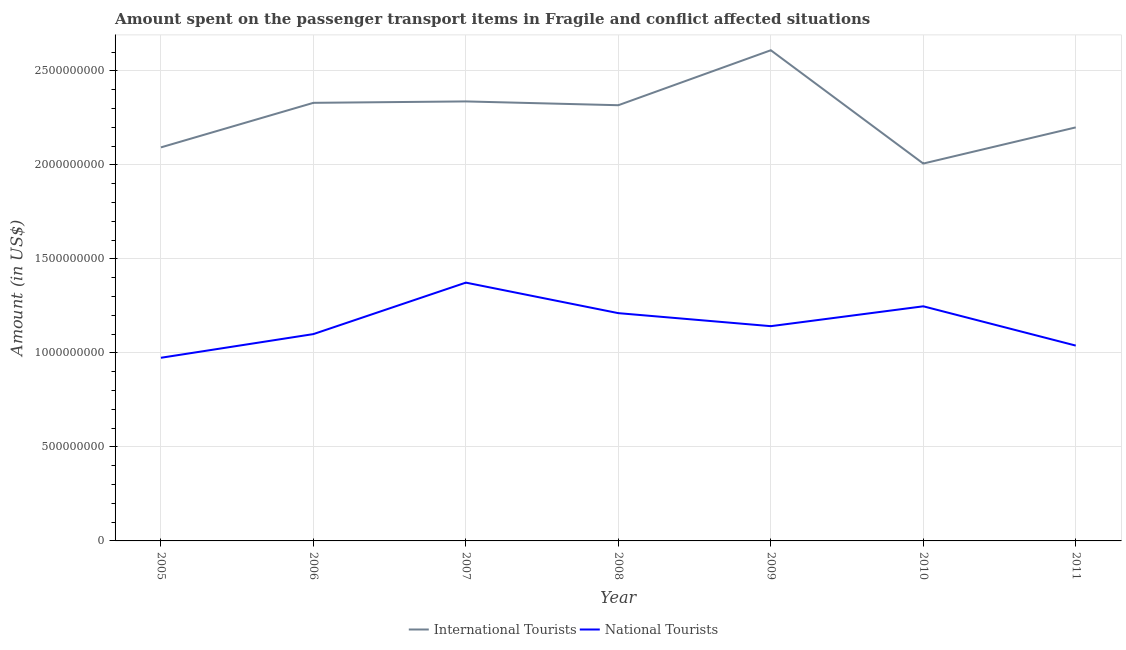Does the line corresponding to amount spent on transport items of international tourists intersect with the line corresponding to amount spent on transport items of national tourists?
Provide a short and direct response. No. Is the number of lines equal to the number of legend labels?
Offer a very short reply. Yes. What is the amount spent on transport items of international tourists in 2007?
Offer a terse response. 2.34e+09. Across all years, what is the maximum amount spent on transport items of international tourists?
Your answer should be compact. 2.61e+09. Across all years, what is the minimum amount spent on transport items of national tourists?
Keep it short and to the point. 9.74e+08. In which year was the amount spent on transport items of national tourists minimum?
Your answer should be compact. 2005. What is the total amount spent on transport items of international tourists in the graph?
Offer a terse response. 1.59e+1. What is the difference between the amount spent on transport items of international tourists in 2010 and that in 2011?
Offer a very short reply. -1.92e+08. What is the difference between the amount spent on transport items of international tourists in 2005 and the amount spent on transport items of national tourists in 2009?
Make the answer very short. 9.51e+08. What is the average amount spent on transport items of international tourists per year?
Your answer should be compact. 2.27e+09. In the year 2005, what is the difference between the amount spent on transport items of international tourists and amount spent on transport items of national tourists?
Make the answer very short. 1.12e+09. In how many years, is the amount spent on transport items of international tourists greater than 2200000000 US$?
Your response must be concise. 4. What is the ratio of the amount spent on transport items of international tourists in 2006 to that in 2007?
Provide a short and direct response. 1. What is the difference between the highest and the second highest amount spent on transport items of international tourists?
Your answer should be compact. 2.72e+08. What is the difference between the highest and the lowest amount spent on transport items of national tourists?
Make the answer very short. 4.00e+08. In how many years, is the amount spent on transport items of national tourists greater than the average amount spent on transport items of national tourists taken over all years?
Your response must be concise. 3. Is the amount spent on transport items of national tourists strictly less than the amount spent on transport items of international tourists over the years?
Give a very brief answer. Yes. How many years are there in the graph?
Offer a terse response. 7. What is the difference between two consecutive major ticks on the Y-axis?
Your answer should be very brief. 5.00e+08. Where does the legend appear in the graph?
Your response must be concise. Bottom center. What is the title of the graph?
Provide a short and direct response. Amount spent on the passenger transport items in Fragile and conflict affected situations. What is the label or title of the X-axis?
Make the answer very short. Year. What is the label or title of the Y-axis?
Offer a very short reply. Amount (in US$). What is the Amount (in US$) in International Tourists in 2005?
Offer a terse response. 2.09e+09. What is the Amount (in US$) in National Tourists in 2005?
Provide a succinct answer. 9.74e+08. What is the Amount (in US$) in International Tourists in 2006?
Your answer should be very brief. 2.33e+09. What is the Amount (in US$) of National Tourists in 2006?
Give a very brief answer. 1.10e+09. What is the Amount (in US$) of International Tourists in 2007?
Your response must be concise. 2.34e+09. What is the Amount (in US$) of National Tourists in 2007?
Give a very brief answer. 1.37e+09. What is the Amount (in US$) of International Tourists in 2008?
Make the answer very short. 2.32e+09. What is the Amount (in US$) in National Tourists in 2008?
Ensure brevity in your answer.  1.21e+09. What is the Amount (in US$) of International Tourists in 2009?
Your answer should be very brief. 2.61e+09. What is the Amount (in US$) of National Tourists in 2009?
Give a very brief answer. 1.14e+09. What is the Amount (in US$) of International Tourists in 2010?
Offer a terse response. 2.01e+09. What is the Amount (in US$) in National Tourists in 2010?
Make the answer very short. 1.25e+09. What is the Amount (in US$) of International Tourists in 2011?
Offer a very short reply. 2.20e+09. What is the Amount (in US$) in National Tourists in 2011?
Provide a succinct answer. 1.04e+09. Across all years, what is the maximum Amount (in US$) of International Tourists?
Provide a short and direct response. 2.61e+09. Across all years, what is the maximum Amount (in US$) in National Tourists?
Provide a short and direct response. 1.37e+09. Across all years, what is the minimum Amount (in US$) of International Tourists?
Your answer should be compact. 2.01e+09. Across all years, what is the minimum Amount (in US$) of National Tourists?
Offer a terse response. 9.74e+08. What is the total Amount (in US$) of International Tourists in the graph?
Offer a terse response. 1.59e+1. What is the total Amount (in US$) of National Tourists in the graph?
Provide a succinct answer. 8.09e+09. What is the difference between the Amount (in US$) in International Tourists in 2005 and that in 2006?
Make the answer very short. -2.37e+08. What is the difference between the Amount (in US$) in National Tourists in 2005 and that in 2006?
Your response must be concise. -1.26e+08. What is the difference between the Amount (in US$) in International Tourists in 2005 and that in 2007?
Make the answer very short. -2.44e+08. What is the difference between the Amount (in US$) in National Tourists in 2005 and that in 2007?
Offer a very short reply. -4.00e+08. What is the difference between the Amount (in US$) of International Tourists in 2005 and that in 2008?
Your response must be concise. -2.24e+08. What is the difference between the Amount (in US$) of National Tourists in 2005 and that in 2008?
Your answer should be compact. -2.37e+08. What is the difference between the Amount (in US$) of International Tourists in 2005 and that in 2009?
Keep it short and to the point. -5.17e+08. What is the difference between the Amount (in US$) in National Tourists in 2005 and that in 2009?
Offer a very short reply. -1.68e+08. What is the difference between the Amount (in US$) of International Tourists in 2005 and that in 2010?
Offer a terse response. 8.60e+07. What is the difference between the Amount (in US$) in National Tourists in 2005 and that in 2010?
Provide a succinct answer. -2.74e+08. What is the difference between the Amount (in US$) in International Tourists in 2005 and that in 2011?
Provide a short and direct response. -1.06e+08. What is the difference between the Amount (in US$) in National Tourists in 2005 and that in 2011?
Make the answer very short. -6.48e+07. What is the difference between the Amount (in US$) of International Tourists in 2006 and that in 2007?
Provide a short and direct response. -7.46e+06. What is the difference between the Amount (in US$) of National Tourists in 2006 and that in 2007?
Keep it short and to the point. -2.74e+08. What is the difference between the Amount (in US$) in International Tourists in 2006 and that in 2008?
Keep it short and to the point. 1.27e+07. What is the difference between the Amount (in US$) in National Tourists in 2006 and that in 2008?
Provide a short and direct response. -1.11e+08. What is the difference between the Amount (in US$) of International Tourists in 2006 and that in 2009?
Provide a short and direct response. -2.80e+08. What is the difference between the Amount (in US$) in National Tourists in 2006 and that in 2009?
Make the answer very short. -4.22e+07. What is the difference between the Amount (in US$) in International Tourists in 2006 and that in 2010?
Your answer should be compact. 3.23e+08. What is the difference between the Amount (in US$) in National Tourists in 2006 and that in 2010?
Provide a succinct answer. -1.48e+08. What is the difference between the Amount (in US$) of International Tourists in 2006 and that in 2011?
Your answer should be very brief. 1.31e+08. What is the difference between the Amount (in US$) in National Tourists in 2006 and that in 2011?
Ensure brevity in your answer.  6.11e+07. What is the difference between the Amount (in US$) of International Tourists in 2007 and that in 2008?
Keep it short and to the point. 2.02e+07. What is the difference between the Amount (in US$) of National Tourists in 2007 and that in 2008?
Your answer should be very brief. 1.62e+08. What is the difference between the Amount (in US$) in International Tourists in 2007 and that in 2009?
Your answer should be compact. -2.72e+08. What is the difference between the Amount (in US$) of National Tourists in 2007 and that in 2009?
Provide a succinct answer. 2.32e+08. What is the difference between the Amount (in US$) of International Tourists in 2007 and that in 2010?
Make the answer very short. 3.30e+08. What is the difference between the Amount (in US$) in National Tourists in 2007 and that in 2010?
Offer a very short reply. 1.26e+08. What is the difference between the Amount (in US$) in International Tourists in 2007 and that in 2011?
Your answer should be very brief. 1.38e+08. What is the difference between the Amount (in US$) in National Tourists in 2007 and that in 2011?
Ensure brevity in your answer.  3.35e+08. What is the difference between the Amount (in US$) of International Tourists in 2008 and that in 2009?
Provide a succinct answer. -2.92e+08. What is the difference between the Amount (in US$) of National Tourists in 2008 and that in 2009?
Give a very brief answer. 6.92e+07. What is the difference between the Amount (in US$) of International Tourists in 2008 and that in 2010?
Offer a terse response. 3.10e+08. What is the difference between the Amount (in US$) in National Tourists in 2008 and that in 2010?
Give a very brief answer. -3.64e+07. What is the difference between the Amount (in US$) in International Tourists in 2008 and that in 2011?
Offer a very short reply. 1.18e+08. What is the difference between the Amount (in US$) of National Tourists in 2008 and that in 2011?
Give a very brief answer. 1.73e+08. What is the difference between the Amount (in US$) of International Tourists in 2009 and that in 2010?
Offer a terse response. 6.03e+08. What is the difference between the Amount (in US$) of National Tourists in 2009 and that in 2010?
Ensure brevity in your answer.  -1.06e+08. What is the difference between the Amount (in US$) in International Tourists in 2009 and that in 2011?
Your answer should be very brief. 4.10e+08. What is the difference between the Amount (in US$) of National Tourists in 2009 and that in 2011?
Give a very brief answer. 1.03e+08. What is the difference between the Amount (in US$) in International Tourists in 2010 and that in 2011?
Provide a succinct answer. -1.92e+08. What is the difference between the Amount (in US$) of National Tourists in 2010 and that in 2011?
Provide a succinct answer. 2.09e+08. What is the difference between the Amount (in US$) of International Tourists in 2005 and the Amount (in US$) of National Tourists in 2006?
Offer a very short reply. 9.93e+08. What is the difference between the Amount (in US$) in International Tourists in 2005 and the Amount (in US$) in National Tourists in 2007?
Provide a succinct answer. 7.19e+08. What is the difference between the Amount (in US$) of International Tourists in 2005 and the Amount (in US$) of National Tourists in 2008?
Provide a short and direct response. 8.82e+08. What is the difference between the Amount (in US$) of International Tourists in 2005 and the Amount (in US$) of National Tourists in 2009?
Ensure brevity in your answer.  9.51e+08. What is the difference between the Amount (in US$) of International Tourists in 2005 and the Amount (in US$) of National Tourists in 2010?
Offer a very short reply. 8.45e+08. What is the difference between the Amount (in US$) in International Tourists in 2005 and the Amount (in US$) in National Tourists in 2011?
Make the answer very short. 1.05e+09. What is the difference between the Amount (in US$) in International Tourists in 2006 and the Amount (in US$) in National Tourists in 2007?
Make the answer very short. 9.56e+08. What is the difference between the Amount (in US$) of International Tourists in 2006 and the Amount (in US$) of National Tourists in 2008?
Your answer should be compact. 1.12e+09. What is the difference between the Amount (in US$) in International Tourists in 2006 and the Amount (in US$) in National Tourists in 2009?
Keep it short and to the point. 1.19e+09. What is the difference between the Amount (in US$) in International Tourists in 2006 and the Amount (in US$) in National Tourists in 2010?
Provide a short and direct response. 1.08e+09. What is the difference between the Amount (in US$) in International Tourists in 2006 and the Amount (in US$) in National Tourists in 2011?
Provide a succinct answer. 1.29e+09. What is the difference between the Amount (in US$) of International Tourists in 2007 and the Amount (in US$) of National Tourists in 2008?
Make the answer very short. 1.13e+09. What is the difference between the Amount (in US$) in International Tourists in 2007 and the Amount (in US$) in National Tourists in 2009?
Provide a short and direct response. 1.20e+09. What is the difference between the Amount (in US$) in International Tourists in 2007 and the Amount (in US$) in National Tourists in 2010?
Give a very brief answer. 1.09e+09. What is the difference between the Amount (in US$) in International Tourists in 2007 and the Amount (in US$) in National Tourists in 2011?
Offer a terse response. 1.30e+09. What is the difference between the Amount (in US$) of International Tourists in 2008 and the Amount (in US$) of National Tourists in 2009?
Your answer should be compact. 1.18e+09. What is the difference between the Amount (in US$) of International Tourists in 2008 and the Amount (in US$) of National Tourists in 2010?
Your response must be concise. 1.07e+09. What is the difference between the Amount (in US$) of International Tourists in 2008 and the Amount (in US$) of National Tourists in 2011?
Give a very brief answer. 1.28e+09. What is the difference between the Amount (in US$) in International Tourists in 2009 and the Amount (in US$) in National Tourists in 2010?
Make the answer very short. 1.36e+09. What is the difference between the Amount (in US$) of International Tourists in 2009 and the Amount (in US$) of National Tourists in 2011?
Give a very brief answer. 1.57e+09. What is the difference between the Amount (in US$) in International Tourists in 2010 and the Amount (in US$) in National Tourists in 2011?
Give a very brief answer. 9.68e+08. What is the average Amount (in US$) in International Tourists per year?
Your response must be concise. 2.27e+09. What is the average Amount (in US$) of National Tourists per year?
Provide a short and direct response. 1.16e+09. In the year 2005, what is the difference between the Amount (in US$) in International Tourists and Amount (in US$) in National Tourists?
Your answer should be very brief. 1.12e+09. In the year 2006, what is the difference between the Amount (in US$) in International Tourists and Amount (in US$) in National Tourists?
Make the answer very short. 1.23e+09. In the year 2007, what is the difference between the Amount (in US$) in International Tourists and Amount (in US$) in National Tourists?
Offer a terse response. 9.64e+08. In the year 2008, what is the difference between the Amount (in US$) of International Tourists and Amount (in US$) of National Tourists?
Provide a succinct answer. 1.11e+09. In the year 2009, what is the difference between the Amount (in US$) of International Tourists and Amount (in US$) of National Tourists?
Provide a short and direct response. 1.47e+09. In the year 2010, what is the difference between the Amount (in US$) of International Tourists and Amount (in US$) of National Tourists?
Keep it short and to the point. 7.59e+08. In the year 2011, what is the difference between the Amount (in US$) of International Tourists and Amount (in US$) of National Tourists?
Offer a terse response. 1.16e+09. What is the ratio of the Amount (in US$) in International Tourists in 2005 to that in 2006?
Your response must be concise. 0.9. What is the ratio of the Amount (in US$) of National Tourists in 2005 to that in 2006?
Keep it short and to the point. 0.89. What is the ratio of the Amount (in US$) of International Tourists in 2005 to that in 2007?
Offer a terse response. 0.9. What is the ratio of the Amount (in US$) in National Tourists in 2005 to that in 2007?
Your answer should be very brief. 0.71. What is the ratio of the Amount (in US$) in International Tourists in 2005 to that in 2008?
Keep it short and to the point. 0.9. What is the ratio of the Amount (in US$) in National Tourists in 2005 to that in 2008?
Keep it short and to the point. 0.8. What is the ratio of the Amount (in US$) in International Tourists in 2005 to that in 2009?
Offer a very short reply. 0.8. What is the ratio of the Amount (in US$) of National Tourists in 2005 to that in 2009?
Offer a very short reply. 0.85. What is the ratio of the Amount (in US$) in International Tourists in 2005 to that in 2010?
Your answer should be compact. 1.04. What is the ratio of the Amount (in US$) in National Tourists in 2005 to that in 2010?
Provide a short and direct response. 0.78. What is the ratio of the Amount (in US$) of International Tourists in 2005 to that in 2011?
Offer a terse response. 0.95. What is the ratio of the Amount (in US$) of National Tourists in 2005 to that in 2011?
Your response must be concise. 0.94. What is the ratio of the Amount (in US$) in National Tourists in 2006 to that in 2007?
Provide a succinct answer. 0.8. What is the ratio of the Amount (in US$) in International Tourists in 2006 to that in 2008?
Keep it short and to the point. 1.01. What is the ratio of the Amount (in US$) in National Tourists in 2006 to that in 2008?
Provide a succinct answer. 0.91. What is the ratio of the Amount (in US$) in International Tourists in 2006 to that in 2009?
Your response must be concise. 0.89. What is the ratio of the Amount (in US$) of National Tourists in 2006 to that in 2009?
Your answer should be very brief. 0.96. What is the ratio of the Amount (in US$) in International Tourists in 2006 to that in 2010?
Offer a very short reply. 1.16. What is the ratio of the Amount (in US$) of National Tourists in 2006 to that in 2010?
Ensure brevity in your answer.  0.88. What is the ratio of the Amount (in US$) in International Tourists in 2006 to that in 2011?
Ensure brevity in your answer.  1.06. What is the ratio of the Amount (in US$) of National Tourists in 2006 to that in 2011?
Make the answer very short. 1.06. What is the ratio of the Amount (in US$) in International Tourists in 2007 to that in 2008?
Give a very brief answer. 1.01. What is the ratio of the Amount (in US$) in National Tourists in 2007 to that in 2008?
Offer a terse response. 1.13. What is the ratio of the Amount (in US$) of International Tourists in 2007 to that in 2009?
Your answer should be compact. 0.9. What is the ratio of the Amount (in US$) in National Tourists in 2007 to that in 2009?
Your response must be concise. 1.2. What is the ratio of the Amount (in US$) of International Tourists in 2007 to that in 2010?
Offer a very short reply. 1.16. What is the ratio of the Amount (in US$) in National Tourists in 2007 to that in 2010?
Give a very brief answer. 1.1. What is the ratio of the Amount (in US$) in International Tourists in 2007 to that in 2011?
Ensure brevity in your answer.  1.06. What is the ratio of the Amount (in US$) of National Tourists in 2007 to that in 2011?
Keep it short and to the point. 1.32. What is the ratio of the Amount (in US$) of International Tourists in 2008 to that in 2009?
Ensure brevity in your answer.  0.89. What is the ratio of the Amount (in US$) of National Tourists in 2008 to that in 2009?
Your response must be concise. 1.06. What is the ratio of the Amount (in US$) of International Tourists in 2008 to that in 2010?
Make the answer very short. 1.15. What is the ratio of the Amount (in US$) of National Tourists in 2008 to that in 2010?
Make the answer very short. 0.97. What is the ratio of the Amount (in US$) of International Tourists in 2008 to that in 2011?
Your response must be concise. 1.05. What is the ratio of the Amount (in US$) in National Tourists in 2008 to that in 2011?
Your response must be concise. 1.17. What is the ratio of the Amount (in US$) of International Tourists in 2009 to that in 2010?
Your answer should be very brief. 1.3. What is the ratio of the Amount (in US$) in National Tourists in 2009 to that in 2010?
Offer a very short reply. 0.92. What is the ratio of the Amount (in US$) of International Tourists in 2009 to that in 2011?
Your answer should be very brief. 1.19. What is the ratio of the Amount (in US$) in National Tourists in 2009 to that in 2011?
Provide a succinct answer. 1.1. What is the ratio of the Amount (in US$) of International Tourists in 2010 to that in 2011?
Your answer should be very brief. 0.91. What is the ratio of the Amount (in US$) in National Tourists in 2010 to that in 2011?
Your answer should be very brief. 1.2. What is the difference between the highest and the second highest Amount (in US$) of International Tourists?
Your response must be concise. 2.72e+08. What is the difference between the highest and the second highest Amount (in US$) of National Tourists?
Your answer should be compact. 1.26e+08. What is the difference between the highest and the lowest Amount (in US$) of International Tourists?
Provide a short and direct response. 6.03e+08. What is the difference between the highest and the lowest Amount (in US$) in National Tourists?
Give a very brief answer. 4.00e+08. 